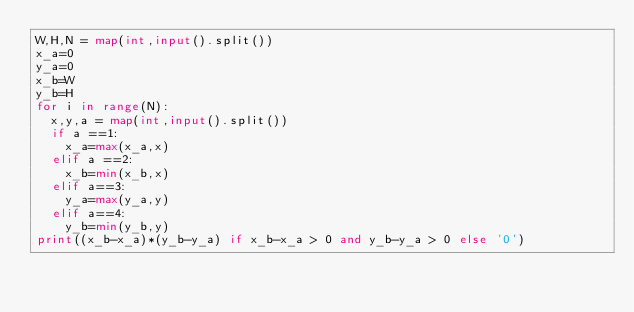<code> <loc_0><loc_0><loc_500><loc_500><_Python_>W,H,N = map(int,input().split())
x_a=0
y_a=0
x_b=W
y_b=H
for i in range(N):
  x,y,a = map(int,input().split())
  if a ==1:
    x_a=max(x_a,x)
  elif a ==2:
    x_b=min(x_b,x)
  elif a==3:
    y_a=max(y_a,y)
  elif a==4:
    y_b=min(y_b,y)
print((x_b-x_a)*(y_b-y_a) if x_b-x_a > 0 and y_b-y_a > 0 else '0')
</code> 